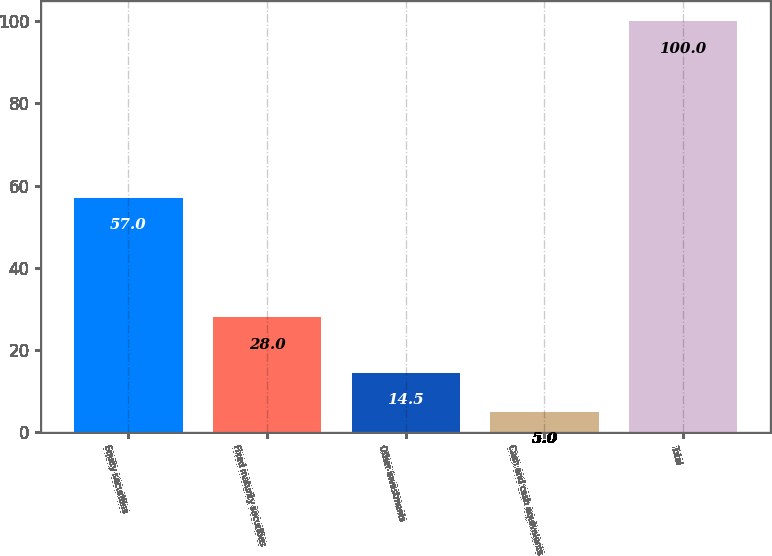Convert chart. <chart><loc_0><loc_0><loc_500><loc_500><bar_chart><fcel>Equity securities<fcel>Fixed maturity securities<fcel>Other investments<fcel>Cash and cash equivalents<fcel>Total<nl><fcel>57<fcel>28<fcel>14.5<fcel>5<fcel>100<nl></chart> 